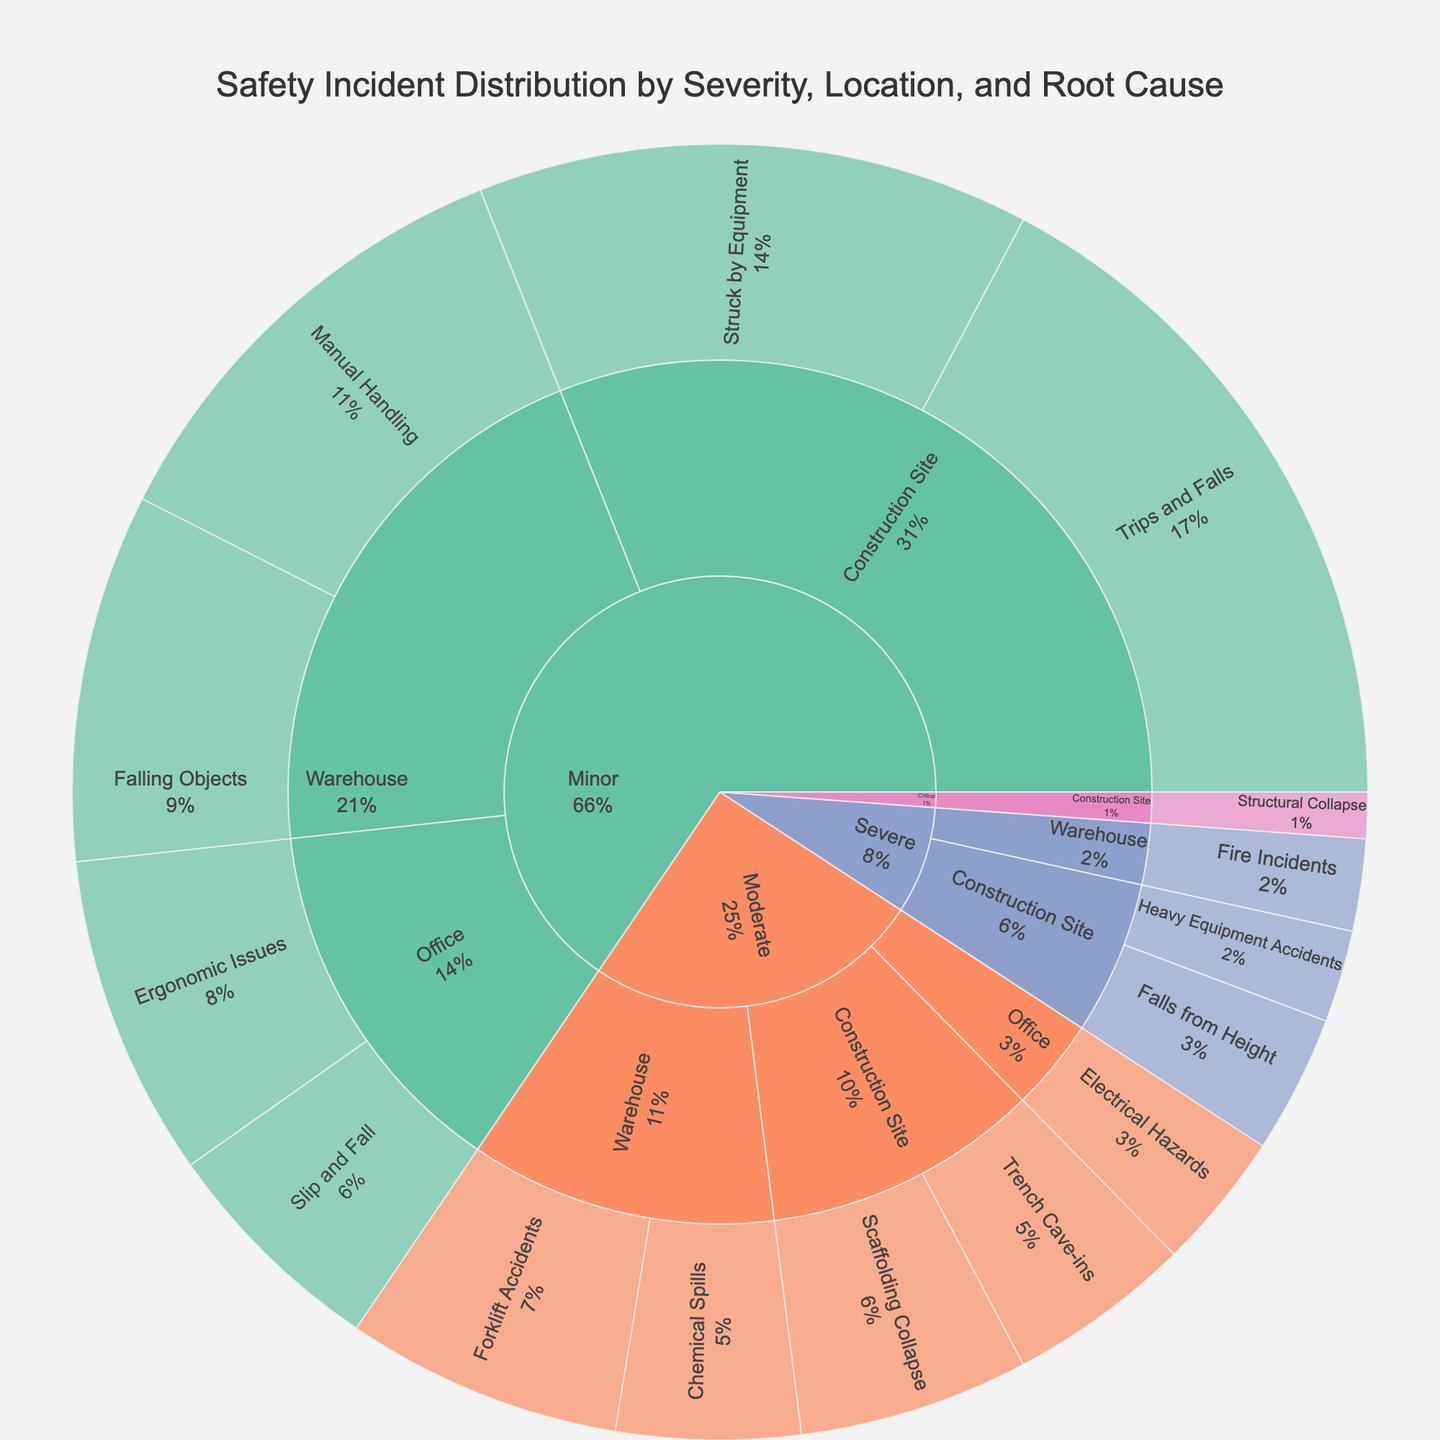What is the title of the figure? The title is typically found at the top of the plot. For this sunburst plot, the title is centered and bold.
Answer: Safety Incident Distribution by Severity, Location, and Root Cause What color is used to represent 'Moderate' severity incidents? Colors for each severity category are assigned differently. In this figure, 'Moderate' incidents are represented using an orange color.
Answer: Orange How many incidents are categorized as 'Severe' in the Warehouse? To find this, navigate to the 'Severe' section, then look for the 'Warehouse' category. It shows two incidents under 'Fire Incidents.'
Answer: 2 Which location has the highest number of 'Minor' severity incidents? Look at the 'Minor' section and compare the incident counts for each location. The location with the highest count is the Construction Site with incidents summing up to 27 (15 for 'Trips and Falls' and 12 for 'Struck by Equipment').
Answer: Construction Site What percentage of 'Severe' incidents are due to 'Falls from Height' at the Construction Site? Within the 'Severe' section under the Construction Site, 'Falls from Height' has 3 incidents. The total for 'Severe' at the Construction Site is 5 incidents (3 for 'Falls from Height' and 2 for 'Heavy Equipment Accidents'). Therefore, the percentage is (3/5) * 100%.
Answer: 60% What are the top two root causes of incidents in the Warehouse across all severities? Aggregate the counts of incidents for each root cause within the Warehouse. Manual calculation shows 'Manual Handling' (10 incidents) and 'Falling Objects' (8 incidents) are the top two.
Answer: Manual Handling, Falling Objects How many incidents are there in total for the 'Office' location? Sum all incidents under the 'Office' location for all severities: (5 + 7) for Minor and 3 for Moderate; resulting in 15 incidents.
Answer: 15 Are there more 'Moderate' severity incidents at the Warehouse or the Construction Site? Compare the incident counts for 'Moderate' severity at these locations: Warehouse has 6 (Forklift Accidents) + 4 (Chemical Spills) = 10. Construction Site has 5 (Scaffolding Collapse) + 4 (Trench Cave-ins) = 9. Thus, the Warehouse has more incidents.
Answer: Warehouse What proportion of incidents at the Construction Site are of 'Critical' severity? Count the total incidents at the Construction Site and then divide the 'Critical' incidents by this total. The Construction Site has 1 'Critical' incident and the total number of incidents (15 + 12 for Minor, 5 + 4 for Moderate, 3 + 2 for Severe, and 1 for Critical) is 42. Therefore, the proportion is 1/42.
Answer: 1/42 